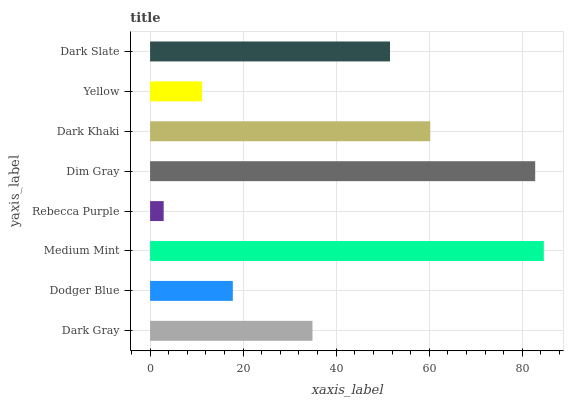Is Rebecca Purple the minimum?
Answer yes or no. Yes. Is Medium Mint the maximum?
Answer yes or no. Yes. Is Dodger Blue the minimum?
Answer yes or no. No. Is Dodger Blue the maximum?
Answer yes or no. No. Is Dark Gray greater than Dodger Blue?
Answer yes or no. Yes. Is Dodger Blue less than Dark Gray?
Answer yes or no. Yes. Is Dodger Blue greater than Dark Gray?
Answer yes or no. No. Is Dark Gray less than Dodger Blue?
Answer yes or no. No. Is Dark Slate the high median?
Answer yes or no. Yes. Is Dark Gray the low median?
Answer yes or no. Yes. Is Dodger Blue the high median?
Answer yes or no. No. Is Yellow the low median?
Answer yes or no. No. 